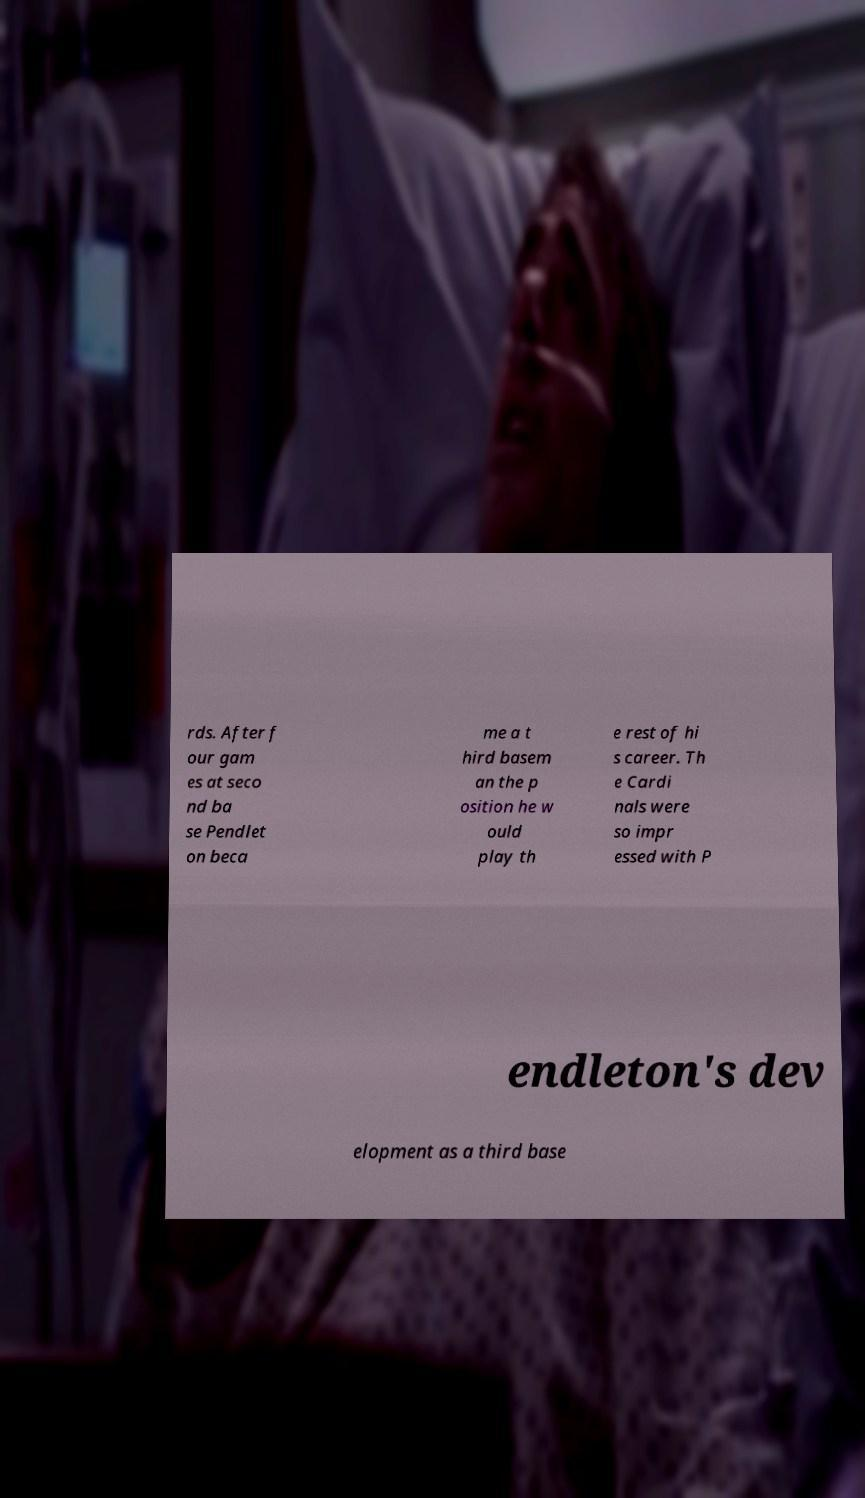Could you assist in decoding the text presented in this image and type it out clearly? rds. After f our gam es at seco nd ba se Pendlet on beca me a t hird basem an the p osition he w ould play th e rest of hi s career. Th e Cardi nals were so impr essed with P endleton's dev elopment as a third base 